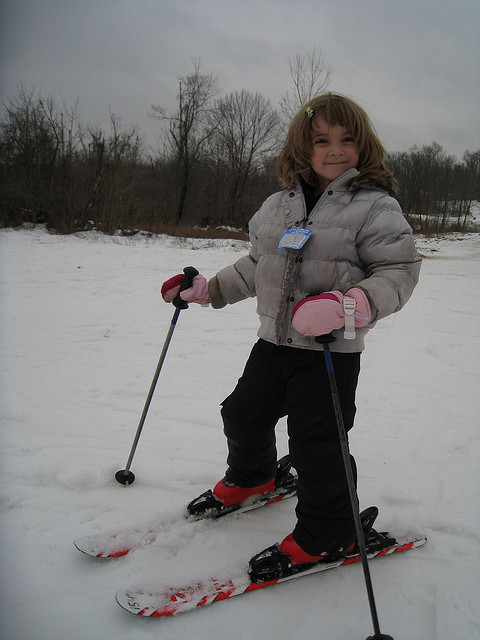Can you tell if this is the girl's first time skiing? It's difficult to ascertain from an image alone, but her stance is steady, and her expression is one of confidence, which could suggest that she has skied before. What tips would you give to a beginner skier like her? Key tips for a beginner skier would include starting on gentle slopes, learning to stop and turn properly, and always being aware of other skiers and your surroundings. 